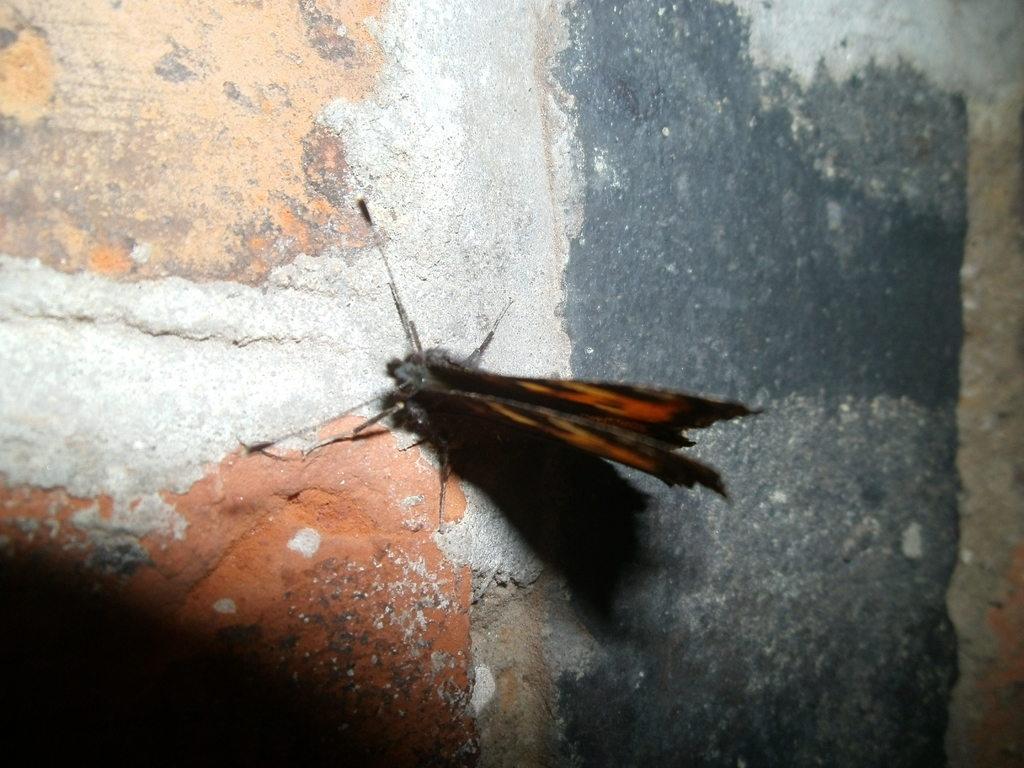How would you summarize this image in a sentence or two? In this picture we can see an insect on a surface. 